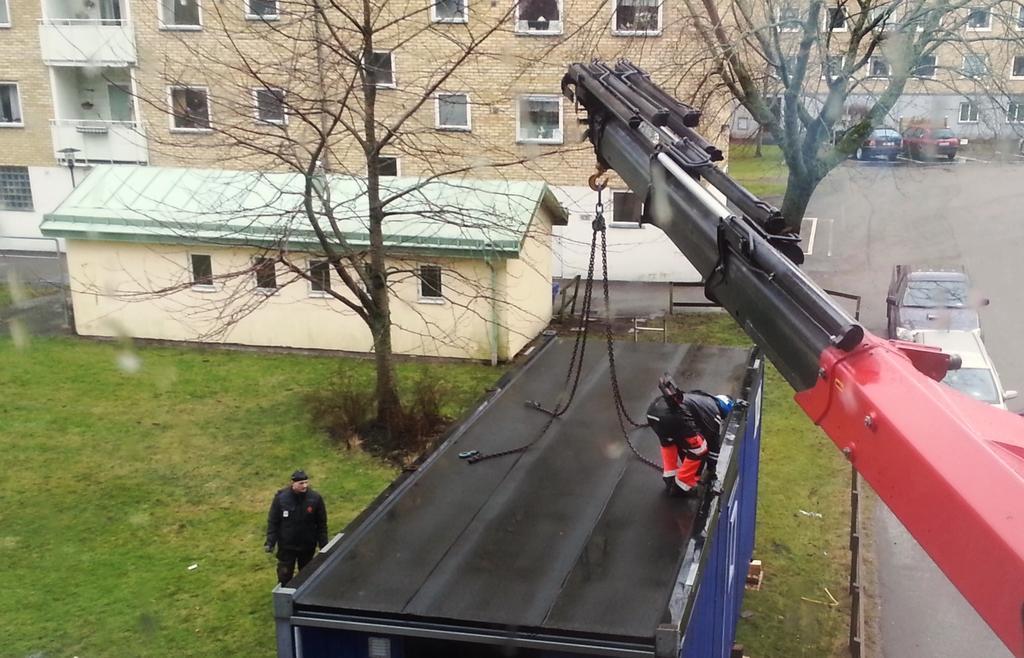Can you describe this image briefly? This image is clicked on the roads. At the bottom, there is a cabin in blue color. To the right, there is a crane. There are two persons wearing black jackets. At the bottom, there is a road and garden. In the background, there are buildings along with trees. 